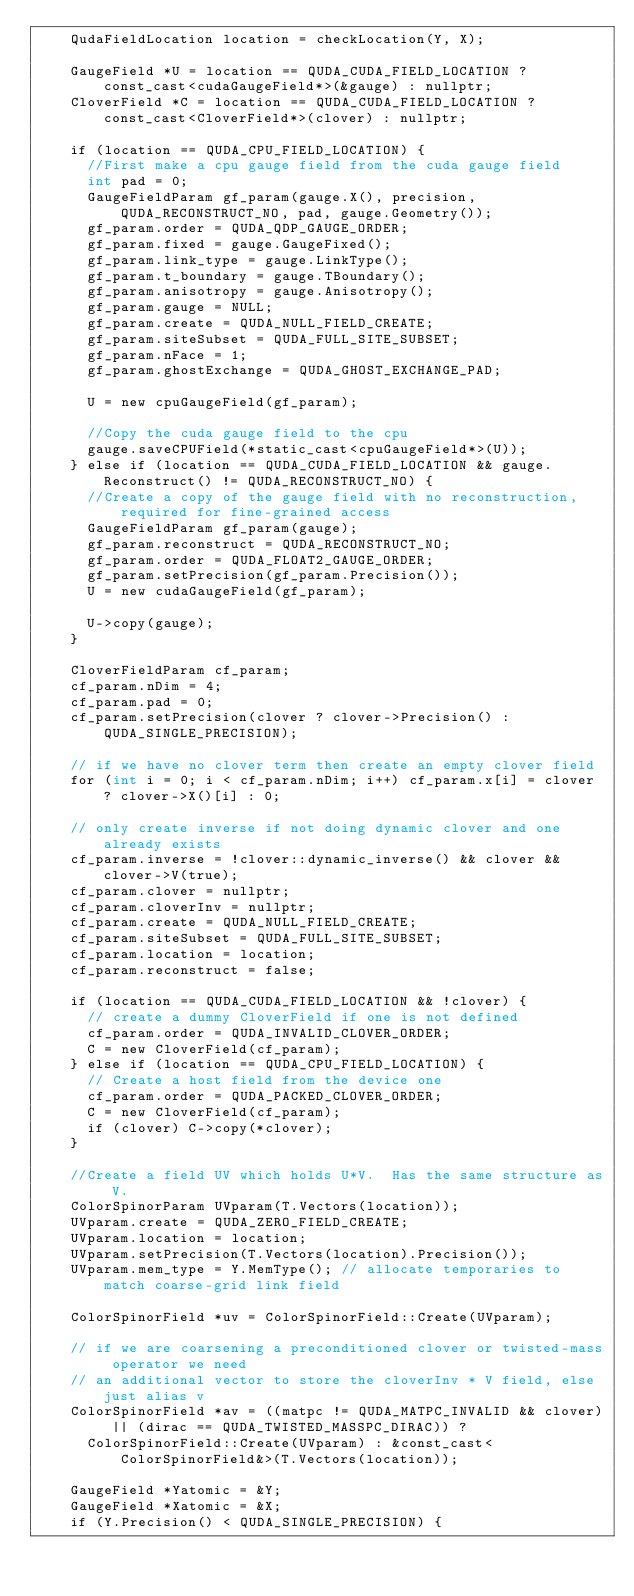<code> <loc_0><loc_0><loc_500><loc_500><_Cuda_>    QudaFieldLocation location = checkLocation(Y, X);

    GaugeField *U = location == QUDA_CUDA_FIELD_LOCATION ? const_cast<cudaGaugeField*>(&gauge) : nullptr;
    CloverField *C = location == QUDA_CUDA_FIELD_LOCATION ? const_cast<CloverField*>(clover) : nullptr;

    if (location == QUDA_CPU_FIELD_LOCATION) {
      //First make a cpu gauge field from the cuda gauge field
      int pad = 0;
      GaugeFieldParam gf_param(gauge.X(), precision, QUDA_RECONSTRUCT_NO, pad, gauge.Geometry());
      gf_param.order = QUDA_QDP_GAUGE_ORDER;
      gf_param.fixed = gauge.GaugeFixed();
      gf_param.link_type = gauge.LinkType();
      gf_param.t_boundary = gauge.TBoundary();
      gf_param.anisotropy = gauge.Anisotropy();
      gf_param.gauge = NULL;
      gf_param.create = QUDA_NULL_FIELD_CREATE;
      gf_param.siteSubset = QUDA_FULL_SITE_SUBSET;
      gf_param.nFace = 1;
      gf_param.ghostExchange = QUDA_GHOST_EXCHANGE_PAD;

      U = new cpuGaugeField(gf_param);

      //Copy the cuda gauge field to the cpu
      gauge.saveCPUField(*static_cast<cpuGaugeField*>(U));
    } else if (location == QUDA_CUDA_FIELD_LOCATION && gauge.Reconstruct() != QUDA_RECONSTRUCT_NO) {
      //Create a copy of the gauge field with no reconstruction, required for fine-grained access
      GaugeFieldParam gf_param(gauge);
      gf_param.reconstruct = QUDA_RECONSTRUCT_NO;
      gf_param.order = QUDA_FLOAT2_GAUGE_ORDER;
      gf_param.setPrecision(gf_param.Precision());
      U = new cudaGaugeField(gf_param);

      U->copy(gauge);
    }

    CloverFieldParam cf_param;
    cf_param.nDim = 4;
    cf_param.pad = 0;
    cf_param.setPrecision(clover ? clover->Precision() : QUDA_SINGLE_PRECISION);

    // if we have no clover term then create an empty clover field
    for (int i = 0; i < cf_param.nDim; i++) cf_param.x[i] = clover ? clover->X()[i] : 0;

    // only create inverse if not doing dynamic clover and one already exists
    cf_param.inverse = !clover::dynamic_inverse() && clover && clover->V(true);
    cf_param.clover = nullptr;
    cf_param.cloverInv = nullptr;
    cf_param.create = QUDA_NULL_FIELD_CREATE;
    cf_param.siteSubset = QUDA_FULL_SITE_SUBSET;
    cf_param.location = location;
    cf_param.reconstruct = false;

    if (location == QUDA_CUDA_FIELD_LOCATION && !clover) {
      // create a dummy CloverField if one is not defined
      cf_param.order = QUDA_INVALID_CLOVER_ORDER;
      C = new CloverField(cf_param);
    } else if (location == QUDA_CPU_FIELD_LOCATION) {
      // Create a host field from the device one
      cf_param.order = QUDA_PACKED_CLOVER_ORDER;
      C = new CloverField(cf_param);
      if (clover) C->copy(*clover);
    }

    //Create a field UV which holds U*V.  Has the same structure as V.
    ColorSpinorParam UVparam(T.Vectors(location));
    UVparam.create = QUDA_ZERO_FIELD_CREATE;
    UVparam.location = location;
    UVparam.setPrecision(T.Vectors(location).Precision());
    UVparam.mem_type = Y.MemType(); // allocate temporaries to match coarse-grid link field

    ColorSpinorField *uv = ColorSpinorField::Create(UVparam);

    // if we are coarsening a preconditioned clover or twisted-mass operator we need
    // an additional vector to store the cloverInv * V field, else just alias v
    ColorSpinorField *av = ((matpc != QUDA_MATPC_INVALID && clover) || (dirac == QUDA_TWISTED_MASSPC_DIRAC)) ?
      ColorSpinorField::Create(UVparam) : &const_cast<ColorSpinorField&>(T.Vectors(location));

    GaugeField *Yatomic = &Y;
    GaugeField *Xatomic = &X;
    if (Y.Precision() < QUDA_SINGLE_PRECISION) {</code> 